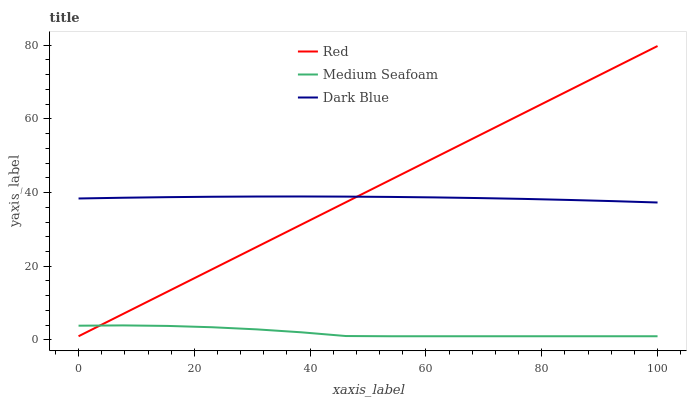Does Medium Seafoam have the minimum area under the curve?
Answer yes or no. Yes. Does Red have the maximum area under the curve?
Answer yes or no. Yes. Does Red have the minimum area under the curve?
Answer yes or no. No. Does Medium Seafoam have the maximum area under the curve?
Answer yes or no. No. Is Red the smoothest?
Answer yes or no. Yes. Is Medium Seafoam the roughest?
Answer yes or no. Yes. Is Medium Seafoam the smoothest?
Answer yes or no. No. Is Red the roughest?
Answer yes or no. No. Does Medium Seafoam have the lowest value?
Answer yes or no. Yes. Does Red have the highest value?
Answer yes or no. Yes. Does Medium Seafoam have the highest value?
Answer yes or no. No. Is Medium Seafoam less than Dark Blue?
Answer yes or no. Yes. Is Dark Blue greater than Medium Seafoam?
Answer yes or no. Yes. Does Dark Blue intersect Red?
Answer yes or no. Yes. Is Dark Blue less than Red?
Answer yes or no. No. Is Dark Blue greater than Red?
Answer yes or no. No. Does Medium Seafoam intersect Dark Blue?
Answer yes or no. No. 